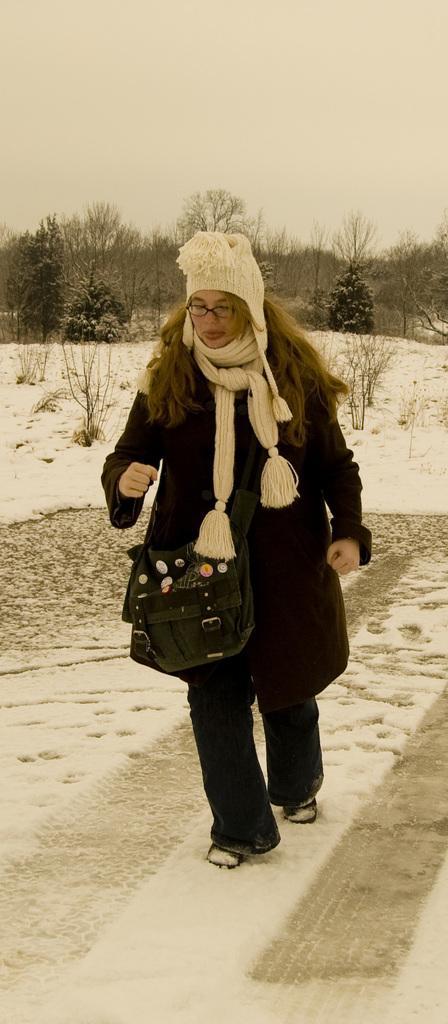Could you give a brief overview of what you see in this image? In the image in the center, we can see one person walking and she is wearing white hat. In the background, we can see the sky, clouds, trees and snow. 